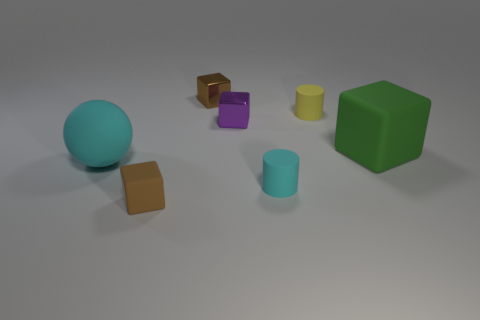The cylinder that is the same color as the large matte sphere is what size?
Offer a terse response. Small. What is the material of the green thing?
Your response must be concise. Rubber. Does the small rubber block have the same color as the large block?
Your answer should be compact. No. Is the number of cyan objects that are behind the tiny brown metallic block less than the number of large green cubes?
Provide a short and direct response. Yes. The small rubber cylinder that is behind the big cyan object is what color?
Offer a terse response. Yellow. What is the shape of the big cyan thing?
Offer a terse response. Sphere. Are there any shiny blocks that are behind the matte block to the right of the brown object that is behind the large matte cube?
Give a very brief answer. Yes. There is a cylinder to the right of the cyan matte object on the right side of the small metallic cube that is in front of the small yellow thing; what is its color?
Ensure brevity in your answer.  Yellow. There is a small purple object that is the same shape as the green matte thing; what material is it?
Provide a short and direct response. Metal. There is a cyan thing that is on the right side of the cube that is in front of the large green object; what size is it?
Give a very brief answer. Small. 